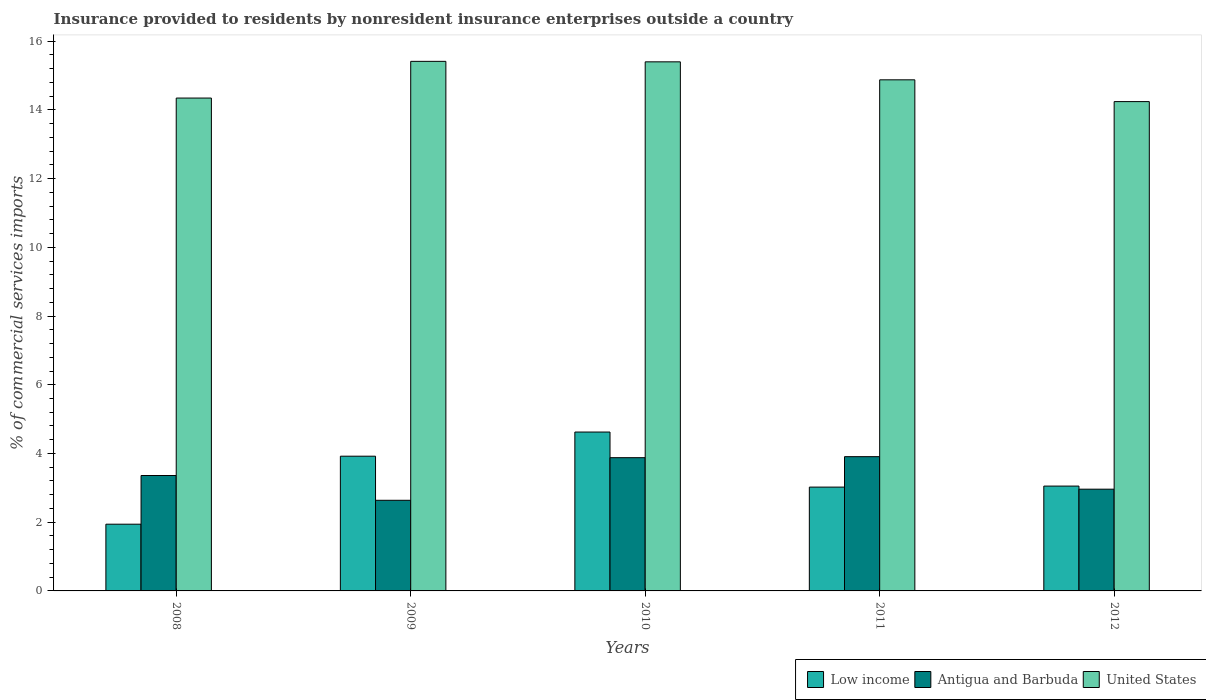How many different coloured bars are there?
Keep it short and to the point. 3. Are the number of bars per tick equal to the number of legend labels?
Offer a very short reply. Yes. Are the number of bars on each tick of the X-axis equal?
Offer a terse response. Yes. What is the label of the 1st group of bars from the left?
Your answer should be very brief. 2008. In how many cases, is the number of bars for a given year not equal to the number of legend labels?
Provide a succinct answer. 0. What is the Insurance provided to residents in Low income in 2009?
Offer a very short reply. 3.92. Across all years, what is the maximum Insurance provided to residents in Low income?
Your response must be concise. 4.62. Across all years, what is the minimum Insurance provided to residents in United States?
Keep it short and to the point. 14.24. In which year was the Insurance provided to residents in Low income maximum?
Ensure brevity in your answer.  2010. What is the total Insurance provided to residents in Antigua and Barbuda in the graph?
Your answer should be compact. 16.74. What is the difference between the Insurance provided to residents in Antigua and Barbuda in 2008 and that in 2011?
Make the answer very short. -0.55. What is the difference between the Insurance provided to residents in United States in 2008 and the Insurance provided to residents in Antigua and Barbuda in 2009?
Keep it short and to the point. 11.71. What is the average Insurance provided to residents in Antigua and Barbuda per year?
Offer a terse response. 3.35. In the year 2011, what is the difference between the Insurance provided to residents in Low income and Insurance provided to residents in United States?
Keep it short and to the point. -11.85. In how many years, is the Insurance provided to residents in Antigua and Barbuda greater than 4.4 %?
Offer a very short reply. 0. What is the ratio of the Insurance provided to residents in Low income in 2008 to that in 2012?
Keep it short and to the point. 0.64. Is the Insurance provided to residents in United States in 2008 less than that in 2010?
Ensure brevity in your answer.  Yes. What is the difference between the highest and the second highest Insurance provided to residents in Antigua and Barbuda?
Provide a succinct answer. 0.03. What is the difference between the highest and the lowest Insurance provided to residents in Antigua and Barbuda?
Ensure brevity in your answer.  1.27. Is the sum of the Insurance provided to residents in United States in 2009 and 2012 greater than the maximum Insurance provided to residents in Low income across all years?
Provide a succinct answer. Yes. What does the 2nd bar from the left in 2012 represents?
Provide a succinct answer. Antigua and Barbuda. What does the 2nd bar from the right in 2012 represents?
Make the answer very short. Antigua and Barbuda. How many bars are there?
Provide a short and direct response. 15. Are all the bars in the graph horizontal?
Offer a terse response. No. How many years are there in the graph?
Provide a short and direct response. 5. Does the graph contain grids?
Ensure brevity in your answer.  No. Where does the legend appear in the graph?
Offer a terse response. Bottom right. How many legend labels are there?
Your answer should be very brief. 3. How are the legend labels stacked?
Keep it short and to the point. Horizontal. What is the title of the graph?
Your response must be concise. Insurance provided to residents by nonresident insurance enterprises outside a country. Does "Colombia" appear as one of the legend labels in the graph?
Provide a short and direct response. No. What is the label or title of the X-axis?
Give a very brief answer. Years. What is the label or title of the Y-axis?
Give a very brief answer. % of commercial services imports. What is the % of commercial services imports in Low income in 2008?
Your answer should be compact. 1.94. What is the % of commercial services imports in Antigua and Barbuda in 2008?
Your answer should be very brief. 3.36. What is the % of commercial services imports in United States in 2008?
Keep it short and to the point. 14.34. What is the % of commercial services imports in Low income in 2009?
Ensure brevity in your answer.  3.92. What is the % of commercial services imports in Antigua and Barbuda in 2009?
Make the answer very short. 2.64. What is the % of commercial services imports in United States in 2009?
Your answer should be very brief. 15.41. What is the % of commercial services imports of Low income in 2010?
Your answer should be very brief. 4.62. What is the % of commercial services imports of Antigua and Barbuda in 2010?
Provide a succinct answer. 3.88. What is the % of commercial services imports of United States in 2010?
Provide a short and direct response. 15.4. What is the % of commercial services imports of Low income in 2011?
Ensure brevity in your answer.  3.02. What is the % of commercial services imports of Antigua and Barbuda in 2011?
Offer a terse response. 3.91. What is the % of commercial services imports of United States in 2011?
Your answer should be very brief. 14.88. What is the % of commercial services imports of Low income in 2012?
Offer a terse response. 3.05. What is the % of commercial services imports of Antigua and Barbuda in 2012?
Provide a short and direct response. 2.96. What is the % of commercial services imports in United States in 2012?
Make the answer very short. 14.24. Across all years, what is the maximum % of commercial services imports of Low income?
Offer a terse response. 4.62. Across all years, what is the maximum % of commercial services imports of Antigua and Barbuda?
Your answer should be very brief. 3.91. Across all years, what is the maximum % of commercial services imports in United States?
Ensure brevity in your answer.  15.41. Across all years, what is the minimum % of commercial services imports in Low income?
Your answer should be very brief. 1.94. Across all years, what is the minimum % of commercial services imports in Antigua and Barbuda?
Your response must be concise. 2.64. Across all years, what is the minimum % of commercial services imports in United States?
Offer a terse response. 14.24. What is the total % of commercial services imports in Low income in the graph?
Ensure brevity in your answer.  16.56. What is the total % of commercial services imports of Antigua and Barbuda in the graph?
Provide a succinct answer. 16.74. What is the total % of commercial services imports of United States in the graph?
Provide a short and direct response. 74.27. What is the difference between the % of commercial services imports in Low income in 2008 and that in 2009?
Your answer should be very brief. -1.98. What is the difference between the % of commercial services imports in Antigua and Barbuda in 2008 and that in 2009?
Your answer should be very brief. 0.72. What is the difference between the % of commercial services imports in United States in 2008 and that in 2009?
Ensure brevity in your answer.  -1.07. What is the difference between the % of commercial services imports in Low income in 2008 and that in 2010?
Provide a short and direct response. -2.68. What is the difference between the % of commercial services imports of Antigua and Barbuda in 2008 and that in 2010?
Offer a terse response. -0.52. What is the difference between the % of commercial services imports in United States in 2008 and that in 2010?
Keep it short and to the point. -1.05. What is the difference between the % of commercial services imports in Low income in 2008 and that in 2011?
Give a very brief answer. -1.08. What is the difference between the % of commercial services imports of Antigua and Barbuda in 2008 and that in 2011?
Your response must be concise. -0.55. What is the difference between the % of commercial services imports of United States in 2008 and that in 2011?
Keep it short and to the point. -0.53. What is the difference between the % of commercial services imports of Low income in 2008 and that in 2012?
Offer a very short reply. -1.11. What is the difference between the % of commercial services imports in Antigua and Barbuda in 2008 and that in 2012?
Ensure brevity in your answer.  0.4. What is the difference between the % of commercial services imports in United States in 2008 and that in 2012?
Give a very brief answer. 0.1. What is the difference between the % of commercial services imports in Low income in 2009 and that in 2010?
Your answer should be very brief. -0.7. What is the difference between the % of commercial services imports of Antigua and Barbuda in 2009 and that in 2010?
Offer a very short reply. -1.24. What is the difference between the % of commercial services imports of United States in 2009 and that in 2010?
Ensure brevity in your answer.  0.01. What is the difference between the % of commercial services imports of Low income in 2009 and that in 2011?
Your answer should be compact. 0.9. What is the difference between the % of commercial services imports in Antigua and Barbuda in 2009 and that in 2011?
Give a very brief answer. -1.27. What is the difference between the % of commercial services imports of United States in 2009 and that in 2011?
Make the answer very short. 0.54. What is the difference between the % of commercial services imports in Low income in 2009 and that in 2012?
Your response must be concise. 0.87. What is the difference between the % of commercial services imports of Antigua and Barbuda in 2009 and that in 2012?
Provide a short and direct response. -0.32. What is the difference between the % of commercial services imports in United States in 2009 and that in 2012?
Provide a short and direct response. 1.17. What is the difference between the % of commercial services imports in Low income in 2010 and that in 2011?
Give a very brief answer. 1.6. What is the difference between the % of commercial services imports of Antigua and Barbuda in 2010 and that in 2011?
Make the answer very short. -0.03. What is the difference between the % of commercial services imports of United States in 2010 and that in 2011?
Offer a terse response. 0.52. What is the difference between the % of commercial services imports of Low income in 2010 and that in 2012?
Provide a short and direct response. 1.57. What is the difference between the % of commercial services imports of Antigua and Barbuda in 2010 and that in 2012?
Your response must be concise. 0.92. What is the difference between the % of commercial services imports in United States in 2010 and that in 2012?
Offer a terse response. 1.16. What is the difference between the % of commercial services imports in Low income in 2011 and that in 2012?
Provide a short and direct response. -0.03. What is the difference between the % of commercial services imports of Antigua and Barbuda in 2011 and that in 2012?
Your answer should be very brief. 0.95. What is the difference between the % of commercial services imports of United States in 2011 and that in 2012?
Offer a very short reply. 0.63. What is the difference between the % of commercial services imports of Low income in 2008 and the % of commercial services imports of Antigua and Barbuda in 2009?
Offer a very short reply. -0.7. What is the difference between the % of commercial services imports in Low income in 2008 and the % of commercial services imports in United States in 2009?
Your answer should be very brief. -13.47. What is the difference between the % of commercial services imports of Antigua and Barbuda in 2008 and the % of commercial services imports of United States in 2009?
Ensure brevity in your answer.  -12.05. What is the difference between the % of commercial services imports in Low income in 2008 and the % of commercial services imports in Antigua and Barbuda in 2010?
Give a very brief answer. -1.94. What is the difference between the % of commercial services imports of Low income in 2008 and the % of commercial services imports of United States in 2010?
Ensure brevity in your answer.  -13.46. What is the difference between the % of commercial services imports of Antigua and Barbuda in 2008 and the % of commercial services imports of United States in 2010?
Provide a short and direct response. -12.04. What is the difference between the % of commercial services imports in Low income in 2008 and the % of commercial services imports in Antigua and Barbuda in 2011?
Provide a short and direct response. -1.97. What is the difference between the % of commercial services imports in Low income in 2008 and the % of commercial services imports in United States in 2011?
Keep it short and to the point. -12.93. What is the difference between the % of commercial services imports of Antigua and Barbuda in 2008 and the % of commercial services imports of United States in 2011?
Provide a short and direct response. -11.52. What is the difference between the % of commercial services imports in Low income in 2008 and the % of commercial services imports in Antigua and Barbuda in 2012?
Give a very brief answer. -1.02. What is the difference between the % of commercial services imports of Low income in 2008 and the % of commercial services imports of United States in 2012?
Make the answer very short. -12.3. What is the difference between the % of commercial services imports of Antigua and Barbuda in 2008 and the % of commercial services imports of United States in 2012?
Offer a terse response. -10.88. What is the difference between the % of commercial services imports in Low income in 2009 and the % of commercial services imports in Antigua and Barbuda in 2010?
Give a very brief answer. 0.04. What is the difference between the % of commercial services imports in Low income in 2009 and the % of commercial services imports in United States in 2010?
Provide a short and direct response. -11.48. What is the difference between the % of commercial services imports in Antigua and Barbuda in 2009 and the % of commercial services imports in United States in 2010?
Your answer should be very brief. -12.76. What is the difference between the % of commercial services imports of Low income in 2009 and the % of commercial services imports of Antigua and Barbuda in 2011?
Offer a very short reply. 0.01. What is the difference between the % of commercial services imports of Low income in 2009 and the % of commercial services imports of United States in 2011?
Offer a terse response. -10.95. What is the difference between the % of commercial services imports of Antigua and Barbuda in 2009 and the % of commercial services imports of United States in 2011?
Your response must be concise. -12.24. What is the difference between the % of commercial services imports of Low income in 2009 and the % of commercial services imports of Antigua and Barbuda in 2012?
Your response must be concise. 0.96. What is the difference between the % of commercial services imports of Low income in 2009 and the % of commercial services imports of United States in 2012?
Your answer should be very brief. -10.32. What is the difference between the % of commercial services imports in Antigua and Barbuda in 2009 and the % of commercial services imports in United States in 2012?
Keep it short and to the point. -11.6. What is the difference between the % of commercial services imports of Low income in 2010 and the % of commercial services imports of Antigua and Barbuda in 2011?
Your response must be concise. 0.72. What is the difference between the % of commercial services imports in Low income in 2010 and the % of commercial services imports in United States in 2011?
Offer a very short reply. -10.25. What is the difference between the % of commercial services imports in Antigua and Barbuda in 2010 and the % of commercial services imports in United States in 2011?
Offer a very short reply. -11. What is the difference between the % of commercial services imports of Low income in 2010 and the % of commercial services imports of Antigua and Barbuda in 2012?
Offer a very short reply. 1.66. What is the difference between the % of commercial services imports in Low income in 2010 and the % of commercial services imports in United States in 2012?
Offer a terse response. -9.62. What is the difference between the % of commercial services imports in Antigua and Barbuda in 2010 and the % of commercial services imports in United States in 2012?
Make the answer very short. -10.36. What is the difference between the % of commercial services imports in Low income in 2011 and the % of commercial services imports in Antigua and Barbuda in 2012?
Your answer should be very brief. 0.06. What is the difference between the % of commercial services imports in Low income in 2011 and the % of commercial services imports in United States in 2012?
Make the answer very short. -11.22. What is the difference between the % of commercial services imports in Antigua and Barbuda in 2011 and the % of commercial services imports in United States in 2012?
Provide a short and direct response. -10.33. What is the average % of commercial services imports in Low income per year?
Your answer should be compact. 3.31. What is the average % of commercial services imports in Antigua and Barbuda per year?
Keep it short and to the point. 3.35. What is the average % of commercial services imports of United States per year?
Your answer should be compact. 14.85. In the year 2008, what is the difference between the % of commercial services imports in Low income and % of commercial services imports in Antigua and Barbuda?
Make the answer very short. -1.42. In the year 2008, what is the difference between the % of commercial services imports in Low income and % of commercial services imports in United States?
Provide a succinct answer. -12.4. In the year 2008, what is the difference between the % of commercial services imports of Antigua and Barbuda and % of commercial services imports of United States?
Keep it short and to the point. -10.99. In the year 2009, what is the difference between the % of commercial services imports in Low income and % of commercial services imports in Antigua and Barbuda?
Provide a succinct answer. 1.28. In the year 2009, what is the difference between the % of commercial services imports in Low income and % of commercial services imports in United States?
Give a very brief answer. -11.49. In the year 2009, what is the difference between the % of commercial services imports in Antigua and Barbuda and % of commercial services imports in United States?
Your response must be concise. -12.77. In the year 2010, what is the difference between the % of commercial services imports of Low income and % of commercial services imports of Antigua and Barbuda?
Your response must be concise. 0.75. In the year 2010, what is the difference between the % of commercial services imports in Low income and % of commercial services imports in United States?
Offer a very short reply. -10.77. In the year 2010, what is the difference between the % of commercial services imports in Antigua and Barbuda and % of commercial services imports in United States?
Your answer should be compact. -11.52. In the year 2011, what is the difference between the % of commercial services imports in Low income and % of commercial services imports in Antigua and Barbuda?
Ensure brevity in your answer.  -0.89. In the year 2011, what is the difference between the % of commercial services imports in Low income and % of commercial services imports in United States?
Your answer should be very brief. -11.85. In the year 2011, what is the difference between the % of commercial services imports in Antigua and Barbuda and % of commercial services imports in United States?
Your answer should be compact. -10.97. In the year 2012, what is the difference between the % of commercial services imports in Low income and % of commercial services imports in Antigua and Barbuda?
Provide a short and direct response. 0.09. In the year 2012, what is the difference between the % of commercial services imports in Low income and % of commercial services imports in United States?
Keep it short and to the point. -11.19. In the year 2012, what is the difference between the % of commercial services imports in Antigua and Barbuda and % of commercial services imports in United States?
Make the answer very short. -11.28. What is the ratio of the % of commercial services imports of Low income in 2008 to that in 2009?
Provide a short and direct response. 0.5. What is the ratio of the % of commercial services imports in Antigua and Barbuda in 2008 to that in 2009?
Your response must be concise. 1.27. What is the ratio of the % of commercial services imports in United States in 2008 to that in 2009?
Ensure brevity in your answer.  0.93. What is the ratio of the % of commercial services imports in Low income in 2008 to that in 2010?
Your answer should be compact. 0.42. What is the ratio of the % of commercial services imports of Antigua and Barbuda in 2008 to that in 2010?
Keep it short and to the point. 0.87. What is the ratio of the % of commercial services imports in United States in 2008 to that in 2010?
Give a very brief answer. 0.93. What is the ratio of the % of commercial services imports of Low income in 2008 to that in 2011?
Ensure brevity in your answer.  0.64. What is the ratio of the % of commercial services imports in Antigua and Barbuda in 2008 to that in 2011?
Make the answer very short. 0.86. What is the ratio of the % of commercial services imports in Low income in 2008 to that in 2012?
Your answer should be very brief. 0.64. What is the ratio of the % of commercial services imports in Antigua and Barbuda in 2008 to that in 2012?
Your answer should be very brief. 1.13. What is the ratio of the % of commercial services imports of Low income in 2009 to that in 2010?
Ensure brevity in your answer.  0.85. What is the ratio of the % of commercial services imports in Antigua and Barbuda in 2009 to that in 2010?
Provide a succinct answer. 0.68. What is the ratio of the % of commercial services imports of Low income in 2009 to that in 2011?
Give a very brief answer. 1.3. What is the ratio of the % of commercial services imports in Antigua and Barbuda in 2009 to that in 2011?
Provide a short and direct response. 0.68. What is the ratio of the % of commercial services imports in United States in 2009 to that in 2011?
Give a very brief answer. 1.04. What is the ratio of the % of commercial services imports of Low income in 2009 to that in 2012?
Provide a short and direct response. 1.29. What is the ratio of the % of commercial services imports in Antigua and Barbuda in 2009 to that in 2012?
Give a very brief answer. 0.89. What is the ratio of the % of commercial services imports of United States in 2009 to that in 2012?
Give a very brief answer. 1.08. What is the ratio of the % of commercial services imports in Low income in 2010 to that in 2011?
Give a very brief answer. 1.53. What is the ratio of the % of commercial services imports of Antigua and Barbuda in 2010 to that in 2011?
Provide a succinct answer. 0.99. What is the ratio of the % of commercial services imports in United States in 2010 to that in 2011?
Offer a terse response. 1.04. What is the ratio of the % of commercial services imports of Low income in 2010 to that in 2012?
Your response must be concise. 1.52. What is the ratio of the % of commercial services imports in Antigua and Barbuda in 2010 to that in 2012?
Keep it short and to the point. 1.31. What is the ratio of the % of commercial services imports of United States in 2010 to that in 2012?
Ensure brevity in your answer.  1.08. What is the ratio of the % of commercial services imports of Low income in 2011 to that in 2012?
Give a very brief answer. 0.99. What is the ratio of the % of commercial services imports in Antigua and Barbuda in 2011 to that in 2012?
Your response must be concise. 1.32. What is the ratio of the % of commercial services imports of United States in 2011 to that in 2012?
Offer a very short reply. 1.04. What is the difference between the highest and the second highest % of commercial services imports in Low income?
Provide a succinct answer. 0.7. What is the difference between the highest and the second highest % of commercial services imports of Antigua and Barbuda?
Offer a very short reply. 0.03. What is the difference between the highest and the second highest % of commercial services imports in United States?
Keep it short and to the point. 0.01. What is the difference between the highest and the lowest % of commercial services imports of Low income?
Your response must be concise. 2.68. What is the difference between the highest and the lowest % of commercial services imports in Antigua and Barbuda?
Offer a terse response. 1.27. What is the difference between the highest and the lowest % of commercial services imports of United States?
Make the answer very short. 1.17. 